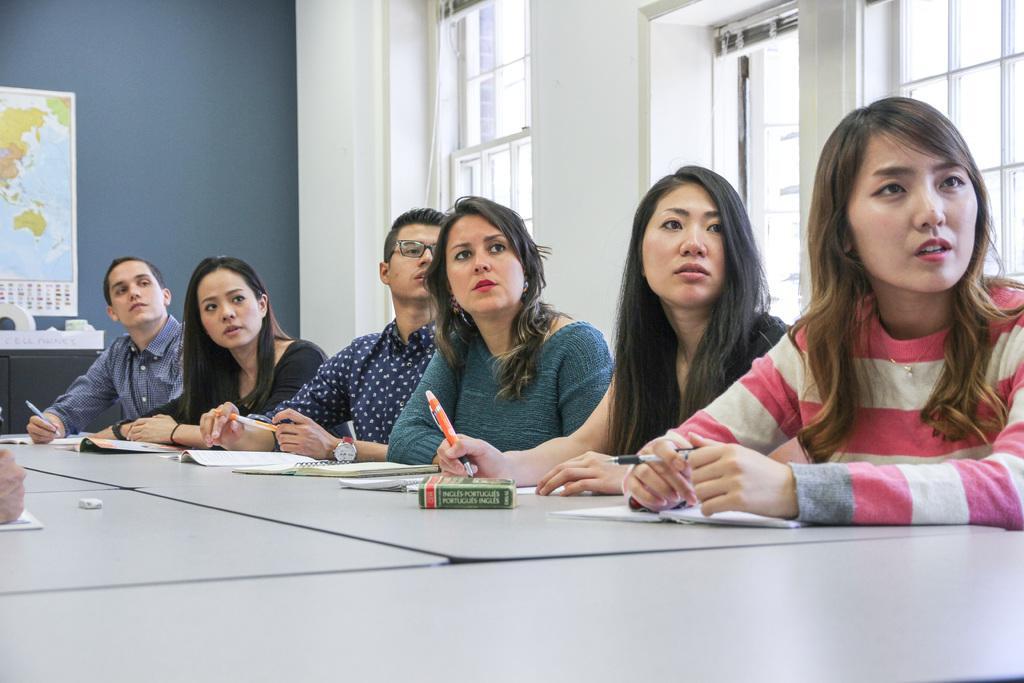In one or two sentences, can you explain what this image depicts? There is a group of persons sitting and holding a pen as we can see in the middle of this image. There is a table at the bottom of this image and there are some kept on it. There is a wall in the background. There are some glass windows on the right side of this image, and there is a map attached to the wall as we can see on the left side of this image. 